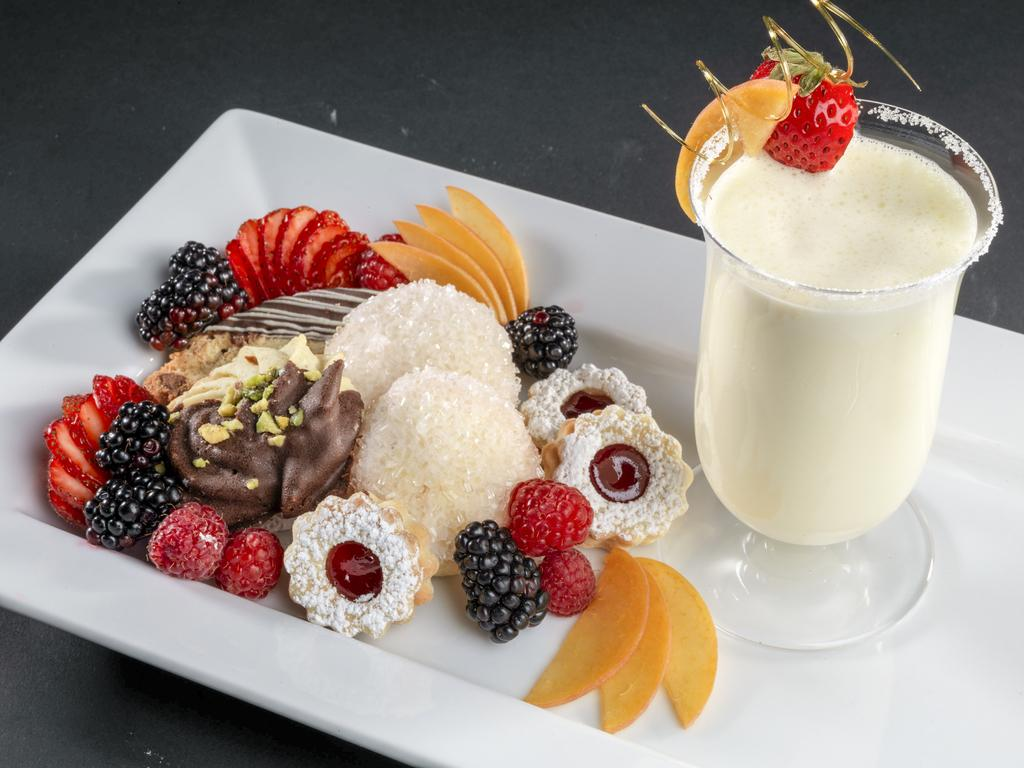What types of food items can be seen in the image? There are food items in the image, but their specific types are not mentioned. What beverage is present in the image? There is a glass of juice in the image. How are the food items and glass of juice arranged in the image? The food items and glass of juice are placed on a tray. Can you tell me how many clovers are on the tray in the image? There is no mention of clovers in the image, so it is not possible to determine their presence or quantity. What type of jam is being served with the food items in the image? There is no mention of jam in the image, so it is not possible to determine its presence or type. 